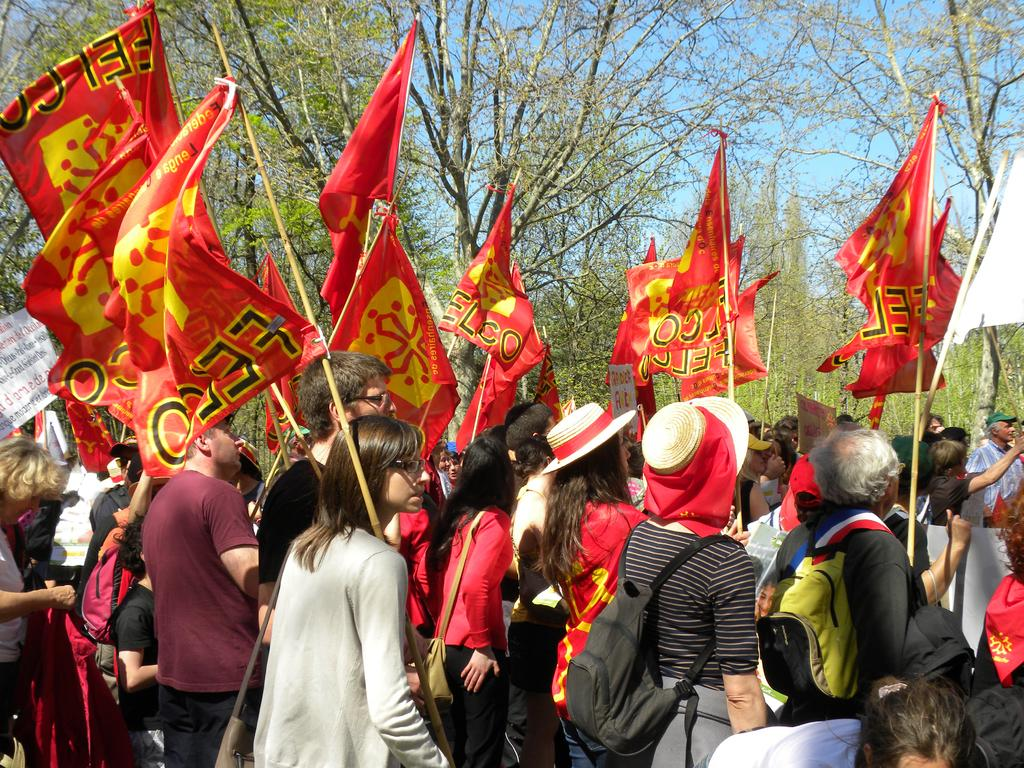How many people are in the image? There is a group of people in the image. What are the people carrying in the image? The people are carrying bags in the image. What else are the people holding in the image? The people are holding flags in the image. What other objects can be seen in the image? There are objects in the image. What type of vegetation is visible in the image? There are trees in the image. What is visible in the background of the image? The sky is visible in the background of the image. How many cows are present in the image? There are no cows present in the image. What type of bubble is being used by the people in the image? There is no bubble present in the image. 